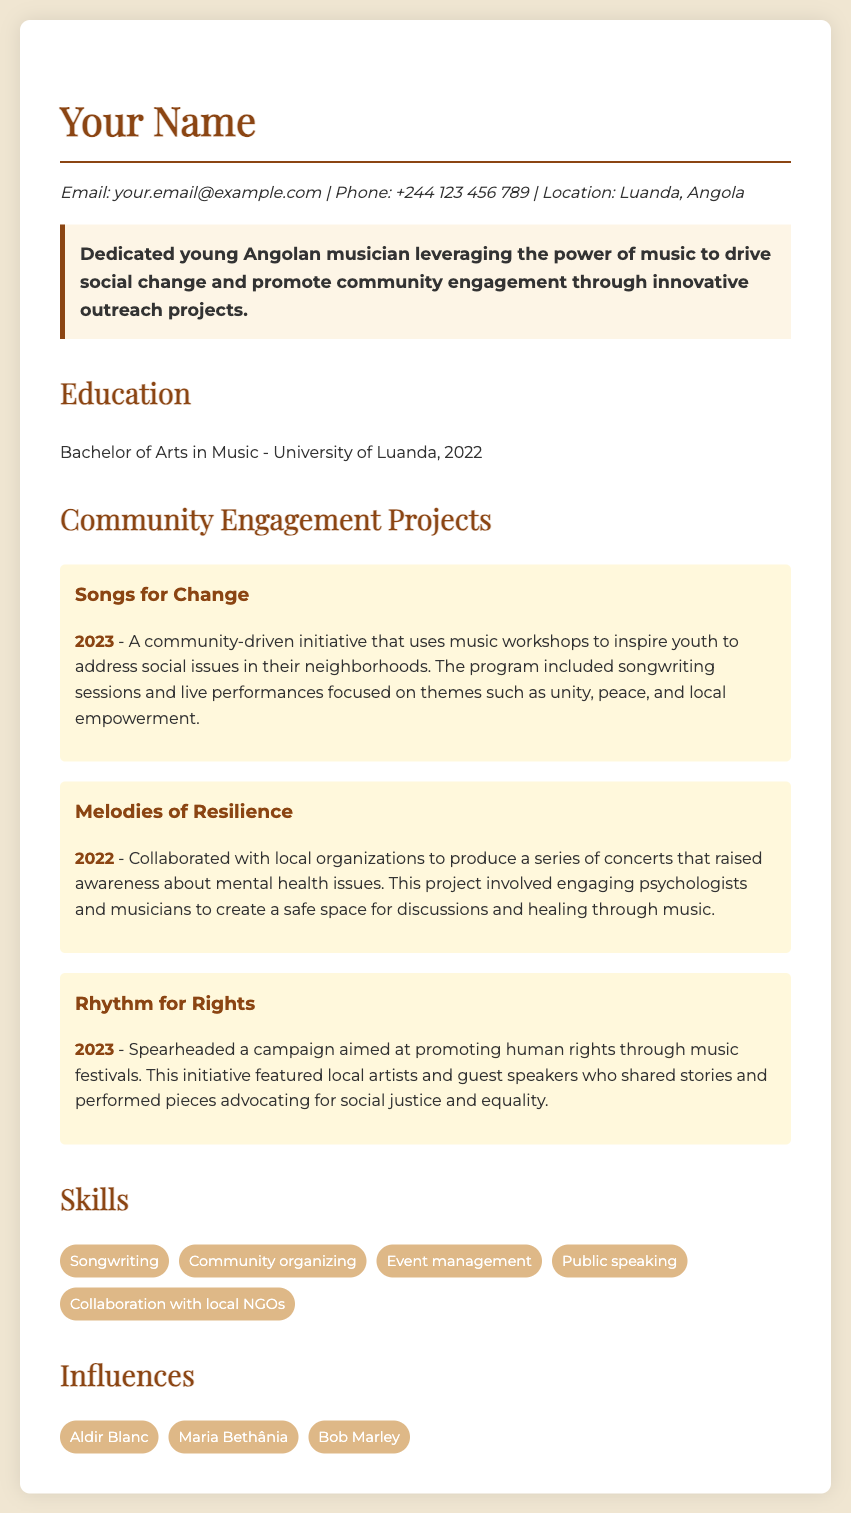what is the name of the initiative that uses music workshops to inspire youth? The initiative is titled "Songs for Change" and focuses on using music to address social issues in neighborhoods.
Answer: Songs for Change in which year did the "Melodies of Resilience" project take place? The "Melodies of Resilience" project was conducted in 2022.
Answer: 2022 what are the themes addressed in the "Songs for Change" initiative? The themes promoted in the initiative include unity, peace, and local empowerment.
Answer: unity, peace, and local empowerment which music legend is listed as an influence in the document? One of the listed influences is "Bob Marley."
Answer: Bob Marley how many skills are mentioned in the skills section? There are five skills listed in the skills section of the document.
Answer: 5 what is the main goal of the "Rhythm for Rights" campaign? The main goal is to promote human rights through music festivals.
Answer: promote human rights who collaborated with the musician for the "Melodies of Resilience" project? The musician collaborated with local organizations and psychologists for this project.
Answer: local organizations and psychologists what degree was obtained by the musician? The musician obtained a Bachelor of Arts in Music from the University of Luanda.
Answer: Bachelor of Arts in Music what year did the "Rhythm for Rights" initiative occur? The "Rhythm for Rights" initiative took place in 2023.
Answer: 2023 